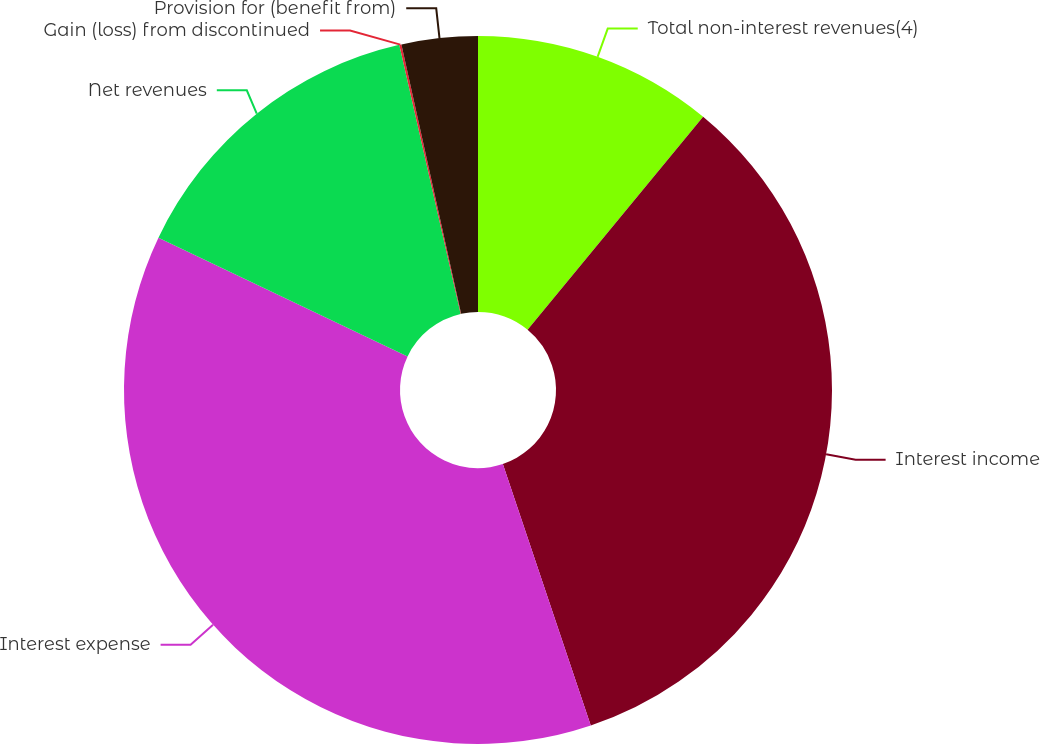Convert chart. <chart><loc_0><loc_0><loc_500><loc_500><pie_chart><fcel>Total non-interest revenues(4)<fcel>Interest income<fcel>Interest expense<fcel>Net revenues<fcel>Gain (loss) from discontinued<fcel>Provision for (benefit from)<nl><fcel>10.97%<fcel>33.87%<fcel>37.24%<fcel>14.35%<fcel>0.1%<fcel>3.47%<nl></chart> 